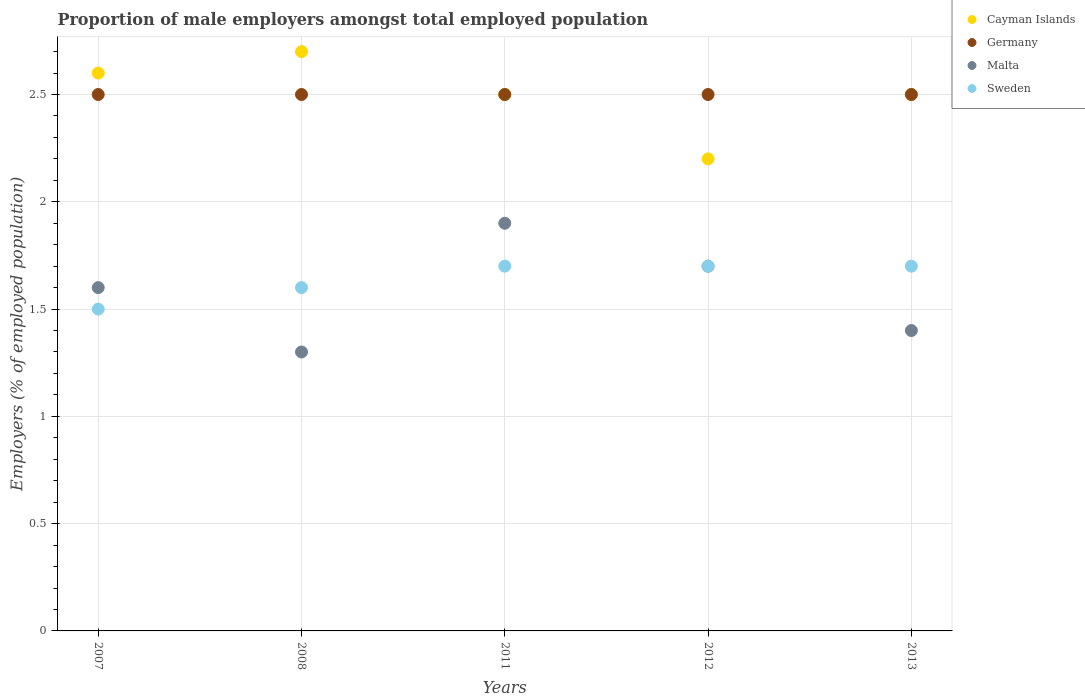How many different coloured dotlines are there?
Your answer should be very brief. 4. Across all years, what is the maximum proportion of male employers in Cayman Islands?
Offer a terse response. 2.7. Across all years, what is the minimum proportion of male employers in Malta?
Your answer should be very brief. 1.3. In which year was the proportion of male employers in Cayman Islands minimum?
Offer a terse response. 2012. What is the total proportion of male employers in Malta in the graph?
Offer a very short reply. 7.9. What is the difference between the proportion of male employers in Germany in 2008 and that in 2011?
Your answer should be compact. 0. What is the difference between the proportion of male employers in Cayman Islands in 2008 and the proportion of male employers in Sweden in 2012?
Your response must be concise. 1. What is the average proportion of male employers in Sweden per year?
Offer a terse response. 1.64. In the year 2013, what is the difference between the proportion of male employers in Malta and proportion of male employers in Germany?
Give a very brief answer. -1.1. What is the ratio of the proportion of male employers in Malta in 2012 to that in 2013?
Your response must be concise. 1.21. Is the proportion of male employers in Cayman Islands in 2007 less than that in 2013?
Offer a terse response. No. What is the difference between the highest and the lowest proportion of male employers in Sweden?
Your answer should be very brief. 0.2. What is the difference between two consecutive major ticks on the Y-axis?
Your response must be concise. 0.5. Are the values on the major ticks of Y-axis written in scientific E-notation?
Provide a short and direct response. No. How many legend labels are there?
Provide a short and direct response. 4. What is the title of the graph?
Keep it short and to the point. Proportion of male employers amongst total employed population. What is the label or title of the X-axis?
Keep it short and to the point. Years. What is the label or title of the Y-axis?
Give a very brief answer. Employers (% of employed population). What is the Employers (% of employed population) in Cayman Islands in 2007?
Ensure brevity in your answer.  2.6. What is the Employers (% of employed population) in Malta in 2007?
Provide a short and direct response. 1.6. What is the Employers (% of employed population) in Sweden in 2007?
Your answer should be very brief. 1.5. What is the Employers (% of employed population) in Cayman Islands in 2008?
Keep it short and to the point. 2.7. What is the Employers (% of employed population) of Germany in 2008?
Provide a short and direct response. 2.5. What is the Employers (% of employed population) of Malta in 2008?
Ensure brevity in your answer.  1.3. What is the Employers (% of employed population) of Sweden in 2008?
Provide a short and direct response. 1.6. What is the Employers (% of employed population) of Cayman Islands in 2011?
Offer a terse response. 2.5. What is the Employers (% of employed population) of Germany in 2011?
Ensure brevity in your answer.  2.5. What is the Employers (% of employed population) of Malta in 2011?
Your answer should be compact. 1.9. What is the Employers (% of employed population) of Sweden in 2011?
Provide a short and direct response. 1.7. What is the Employers (% of employed population) in Cayman Islands in 2012?
Your response must be concise. 2.2. What is the Employers (% of employed population) of Germany in 2012?
Ensure brevity in your answer.  2.5. What is the Employers (% of employed population) of Malta in 2012?
Ensure brevity in your answer.  1.7. What is the Employers (% of employed population) of Sweden in 2012?
Give a very brief answer. 1.7. What is the Employers (% of employed population) in Malta in 2013?
Provide a succinct answer. 1.4. What is the Employers (% of employed population) in Sweden in 2013?
Offer a terse response. 1.7. Across all years, what is the maximum Employers (% of employed population) of Cayman Islands?
Keep it short and to the point. 2.7. Across all years, what is the maximum Employers (% of employed population) of Germany?
Offer a very short reply. 2.5. Across all years, what is the maximum Employers (% of employed population) in Malta?
Keep it short and to the point. 1.9. Across all years, what is the maximum Employers (% of employed population) of Sweden?
Your answer should be very brief. 1.7. Across all years, what is the minimum Employers (% of employed population) of Cayman Islands?
Provide a short and direct response. 2.2. Across all years, what is the minimum Employers (% of employed population) of Malta?
Offer a very short reply. 1.3. What is the total Employers (% of employed population) in Cayman Islands in the graph?
Ensure brevity in your answer.  12.5. What is the total Employers (% of employed population) in Sweden in the graph?
Provide a short and direct response. 8.2. What is the difference between the Employers (% of employed population) in Sweden in 2007 and that in 2008?
Keep it short and to the point. -0.1. What is the difference between the Employers (% of employed population) of Cayman Islands in 2007 and that in 2011?
Offer a very short reply. 0.1. What is the difference between the Employers (% of employed population) of Sweden in 2007 and that in 2011?
Provide a short and direct response. -0.2. What is the difference between the Employers (% of employed population) in Sweden in 2007 and that in 2012?
Offer a terse response. -0.2. What is the difference between the Employers (% of employed population) in Cayman Islands in 2007 and that in 2013?
Ensure brevity in your answer.  0.1. What is the difference between the Employers (% of employed population) in Germany in 2007 and that in 2013?
Your response must be concise. 0. What is the difference between the Employers (% of employed population) in Malta in 2007 and that in 2013?
Keep it short and to the point. 0.2. What is the difference between the Employers (% of employed population) in Malta in 2008 and that in 2011?
Your answer should be very brief. -0.6. What is the difference between the Employers (% of employed population) of Sweden in 2008 and that in 2011?
Provide a short and direct response. -0.1. What is the difference between the Employers (% of employed population) in Cayman Islands in 2008 and that in 2012?
Your answer should be compact. 0.5. What is the difference between the Employers (% of employed population) in Germany in 2008 and that in 2012?
Your answer should be very brief. 0. What is the difference between the Employers (% of employed population) of Cayman Islands in 2008 and that in 2013?
Give a very brief answer. 0.2. What is the difference between the Employers (% of employed population) of Germany in 2008 and that in 2013?
Give a very brief answer. 0. What is the difference between the Employers (% of employed population) in Sweden in 2008 and that in 2013?
Make the answer very short. -0.1. What is the difference between the Employers (% of employed population) in Cayman Islands in 2011 and that in 2012?
Ensure brevity in your answer.  0.3. What is the difference between the Employers (% of employed population) of Germany in 2011 and that in 2012?
Provide a succinct answer. 0. What is the difference between the Employers (% of employed population) of Sweden in 2011 and that in 2012?
Provide a succinct answer. 0. What is the difference between the Employers (% of employed population) in Germany in 2011 and that in 2013?
Provide a succinct answer. 0. What is the difference between the Employers (% of employed population) of Sweden in 2011 and that in 2013?
Your response must be concise. 0. What is the difference between the Employers (% of employed population) in Germany in 2012 and that in 2013?
Offer a very short reply. 0. What is the difference between the Employers (% of employed population) of Cayman Islands in 2007 and the Employers (% of employed population) of Germany in 2008?
Keep it short and to the point. 0.1. What is the difference between the Employers (% of employed population) of Cayman Islands in 2007 and the Employers (% of employed population) of Malta in 2008?
Ensure brevity in your answer.  1.3. What is the difference between the Employers (% of employed population) of Germany in 2007 and the Employers (% of employed population) of Malta in 2008?
Provide a succinct answer. 1.2. What is the difference between the Employers (% of employed population) in Germany in 2007 and the Employers (% of employed population) in Sweden in 2008?
Your answer should be compact. 0.9. What is the difference between the Employers (% of employed population) of Malta in 2007 and the Employers (% of employed population) of Sweden in 2008?
Your answer should be very brief. 0. What is the difference between the Employers (% of employed population) in Cayman Islands in 2007 and the Employers (% of employed population) in Germany in 2011?
Your answer should be very brief. 0.1. What is the difference between the Employers (% of employed population) in Cayman Islands in 2007 and the Employers (% of employed population) in Malta in 2011?
Keep it short and to the point. 0.7. What is the difference between the Employers (% of employed population) in Cayman Islands in 2007 and the Employers (% of employed population) in Sweden in 2011?
Provide a succinct answer. 0.9. What is the difference between the Employers (% of employed population) of Germany in 2007 and the Employers (% of employed population) of Malta in 2011?
Make the answer very short. 0.6. What is the difference between the Employers (% of employed population) in Malta in 2007 and the Employers (% of employed population) in Sweden in 2011?
Make the answer very short. -0.1. What is the difference between the Employers (% of employed population) of Cayman Islands in 2007 and the Employers (% of employed population) of Germany in 2013?
Make the answer very short. 0.1. What is the difference between the Employers (% of employed population) in Cayman Islands in 2007 and the Employers (% of employed population) in Malta in 2013?
Offer a very short reply. 1.2. What is the difference between the Employers (% of employed population) in Cayman Islands in 2007 and the Employers (% of employed population) in Sweden in 2013?
Provide a short and direct response. 0.9. What is the difference between the Employers (% of employed population) of Germany in 2007 and the Employers (% of employed population) of Malta in 2013?
Keep it short and to the point. 1.1. What is the difference between the Employers (% of employed population) in Germany in 2007 and the Employers (% of employed population) in Sweden in 2013?
Provide a succinct answer. 0.8. What is the difference between the Employers (% of employed population) in Malta in 2007 and the Employers (% of employed population) in Sweden in 2013?
Offer a very short reply. -0.1. What is the difference between the Employers (% of employed population) in Cayman Islands in 2008 and the Employers (% of employed population) in Sweden in 2011?
Provide a short and direct response. 1. What is the difference between the Employers (% of employed population) of Germany in 2008 and the Employers (% of employed population) of Malta in 2011?
Provide a succinct answer. 0.6. What is the difference between the Employers (% of employed population) in Malta in 2008 and the Employers (% of employed population) in Sweden in 2012?
Give a very brief answer. -0.4. What is the difference between the Employers (% of employed population) of Cayman Islands in 2008 and the Employers (% of employed population) of Malta in 2013?
Ensure brevity in your answer.  1.3. What is the difference between the Employers (% of employed population) in Malta in 2008 and the Employers (% of employed population) in Sweden in 2013?
Offer a very short reply. -0.4. What is the difference between the Employers (% of employed population) of Cayman Islands in 2011 and the Employers (% of employed population) of Malta in 2012?
Provide a succinct answer. 0.8. What is the difference between the Employers (% of employed population) in Germany in 2011 and the Employers (% of employed population) in Malta in 2012?
Give a very brief answer. 0.8. What is the difference between the Employers (% of employed population) of Germany in 2011 and the Employers (% of employed population) of Sweden in 2012?
Your answer should be compact. 0.8. What is the difference between the Employers (% of employed population) in Malta in 2011 and the Employers (% of employed population) in Sweden in 2012?
Make the answer very short. 0.2. What is the difference between the Employers (% of employed population) in Cayman Islands in 2011 and the Employers (% of employed population) in Sweden in 2013?
Offer a terse response. 0.8. What is the difference between the Employers (% of employed population) of Germany in 2011 and the Employers (% of employed population) of Malta in 2013?
Provide a short and direct response. 1.1. What is the difference between the Employers (% of employed population) in Cayman Islands in 2012 and the Employers (% of employed population) in Germany in 2013?
Your response must be concise. -0.3. What is the difference between the Employers (% of employed population) in Cayman Islands in 2012 and the Employers (% of employed population) in Sweden in 2013?
Offer a very short reply. 0.5. What is the average Employers (% of employed population) of Cayman Islands per year?
Make the answer very short. 2.5. What is the average Employers (% of employed population) in Malta per year?
Make the answer very short. 1.58. What is the average Employers (% of employed population) in Sweden per year?
Offer a very short reply. 1.64. In the year 2007, what is the difference between the Employers (% of employed population) in Cayman Islands and Employers (% of employed population) in Germany?
Keep it short and to the point. 0.1. In the year 2007, what is the difference between the Employers (% of employed population) in Cayman Islands and Employers (% of employed population) in Malta?
Your response must be concise. 1. In the year 2007, what is the difference between the Employers (% of employed population) in Germany and Employers (% of employed population) in Malta?
Make the answer very short. 0.9. In the year 2007, what is the difference between the Employers (% of employed population) in Germany and Employers (% of employed population) in Sweden?
Your answer should be compact. 1. In the year 2007, what is the difference between the Employers (% of employed population) of Malta and Employers (% of employed population) of Sweden?
Your response must be concise. 0.1. In the year 2008, what is the difference between the Employers (% of employed population) of Cayman Islands and Employers (% of employed population) of Germany?
Provide a succinct answer. 0.2. In the year 2008, what is the difference between the Employers (% of employed population) in Germany and Employers (% of employed population) in Malta?
Provide a short and direct response. 1.2. In the year 2008, what is the difference between the Employers (% of employed population) in Malta and Employers (% of employed population) in Sweden?
Your answer should be very brief. -0.3. In the year 2011, what is the difference between the Employers (% of employed population) in Cayman Islands and Employers (% of employed population) in Germany?
Give a very brief answer. 0. In the year 2011, what is the difference between the Employers (% of employed population) of Cayman Islands and Employers (% of employed population) of Malta?
Your answer should be compact. 0.6. In the year 2011, what is the difference between the Employers (% of employed population) in Cayman Islands and Employers (% of employed population) in Sweden?
Keep it short and to the point. 0.8. In the year 2011, what is the difference between the Employers (% of employed population) of Germany and Employers (% of employed population) of Malta?
Keep it short and to the point. 0.6. In the year 2012, what is the difference between the Employers (% of employed population) in Cayman Islands and Employers (% of employed population) in Malta?
Make the answer very short. 0.5. In the year 2012, what is the difference between the Employers (% of employed population) in Cayman Islands and Employers (% of employed population) in Sweden?
Provide a short and direct response. 0.5. In the year 2012, what is the difference between the Employers (% of employed population) in Germany and Employers (% of employed population) in Sweden?
Provide a short and direct response. 0.8. In the year 2012, what is the difference between the Employers (% of employed population) in Malta and Employers (% of employed population) in Sweden?
Keep it short and to the point. 0. In the year 2013, what is the difference between the Employers (% of employed population) of Germany and Employers (% of employed population) of Sweden?
Offer a terse response. 0.8. What is the ratio of the Employers (% of employed population) of Cayman Islands in 2007 to that in 2008?
Make the answer very short. 0.96. What is the ratio of the Employers (% of employed population) in Malta in 2007 to that in 2008?
Offer a very short reply. 1.23. What is the ratio of the Employers (% of employed population) in Sweden in 2007 to that in 2008?
Offer a terse response. 0.94. What is the ratio of the Employers (% of employed population) in Germany in 2007 to that in 2011?
Your answer should be compact. 1. What is the ratio of the Employers (% of employed population) of Malta in 2007 to that in 2011?
Provide a short and direct response. 0.84. What is the ratio of the Employers (% of employed population) in Sweden in 2007 to that in 2011?
Offer a very short reply. 0.88. What is the ratio of the Employers (% of employed population) of Cayman Islands in 2007 to that in 2012?
Offer a very short reply. 1.18. What is the ratio of the Employers (% of employed population) of Germany in 2007 to that in 2012?
Provide a succinct answer. 1. What is the ratio of the Employers (% of employed population) in Sweden in 2007 to that in 2012?
Offer a terse response. 0.88. What is the ratio of the Employers (% of employed population) of Cayman Islands in 2007 to that in 2013?
Offer a terse response. 1.04. What is the ratio of the Employers (% of employed population) in Germany in 2007 to that in 2013?
Ensure brevity in your answer.  1. What is the ratio of the Employers (% of employed population) of Sweden in 2007 to that in 2013?
Provide a succinct answer. 0.88. What is the ratio of the Employers (% of employed population) in Cayman Islands in 2008 to that in 2011?
Your answer should be compact. 1.08. What is the ratio of the Employers (% of employed population) of Malta in 2008 to that in 2011?
Provide a short and direct response. 0.68. What is the ratio of the Employers (% of employed population) of Sweden in 2008 to that in 2011?
Offer a terse response. 0.94. What is the ratio of the Employers (% of employed population) of Cayman Islands in 2008 to that in 2012?
Keep it short and to the point. 1.23. What is the ratio of the Employers (% of employed population) in Germany in 2008 to that in 2012?
Offer a very short reply. 1. What is the ratio of the Employers (% of employed population) in Malta in 2008 to that in 2012?
Ensure brevity in your answer.  0.76. What is the ratio of the Employers (% of employed population) in Germany in 2008 to that in 2013?
Provide a succinct answer. 1. What is the ratio of the Employers (% of employed population) of Cayman Islands in 2011 to that in 2012?
Provide a short and direct response. 1.14. What is the ratio of the Employers (% of employed population) of Malta in 2011 to that in 2012?
Offer a very short reply. 1.12. What is the ratio of the Employers (% of employed population) in Sweden in 2011 to that in 2012?
Give a very brief answer. 1. What is the ratio of the Employers (% of employed population) in Cayman Islands in 2011 to that in 2013?
Make the answer very short. 1. What is the ratio of the Employers (% of employed population) of Malta in 2011 to that in 2013?
Give a very brief answer. 1.36. What is the ratio of the Employers (% of employed population) in Cayman Islands in 2012 to that in 2013?
Provide a succinct answer. 0.88. What is the ratio of the Employers (% of employed population) in Malta in 2012 to that in 2013?
Offer a very short reply. 1.21. What is the ratio of the Employers (% of employed population) in Sweden in 2012 to that in 2013?
Keep it short and to the point. 1. What is the difference between the highest and the second highest Employers (% of employed population) of Cayman Islands?
Keep it short and to the point. 0.1. What is the difference between the highest and the second highest Employers (% of employed population) in Malta?
Provide a succinct answer. 0.2. 